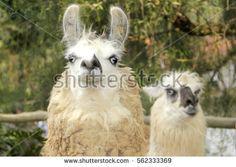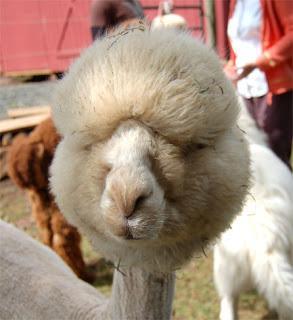The first image is the image on the left, the second image is the image on the right. For the images displayed, is the sentence "One image contains two face-forward llamas with shaggy necks, and the other image includes at least one llama with a sheared neck and round head." factually correct? Answer yes or no. Yes. 